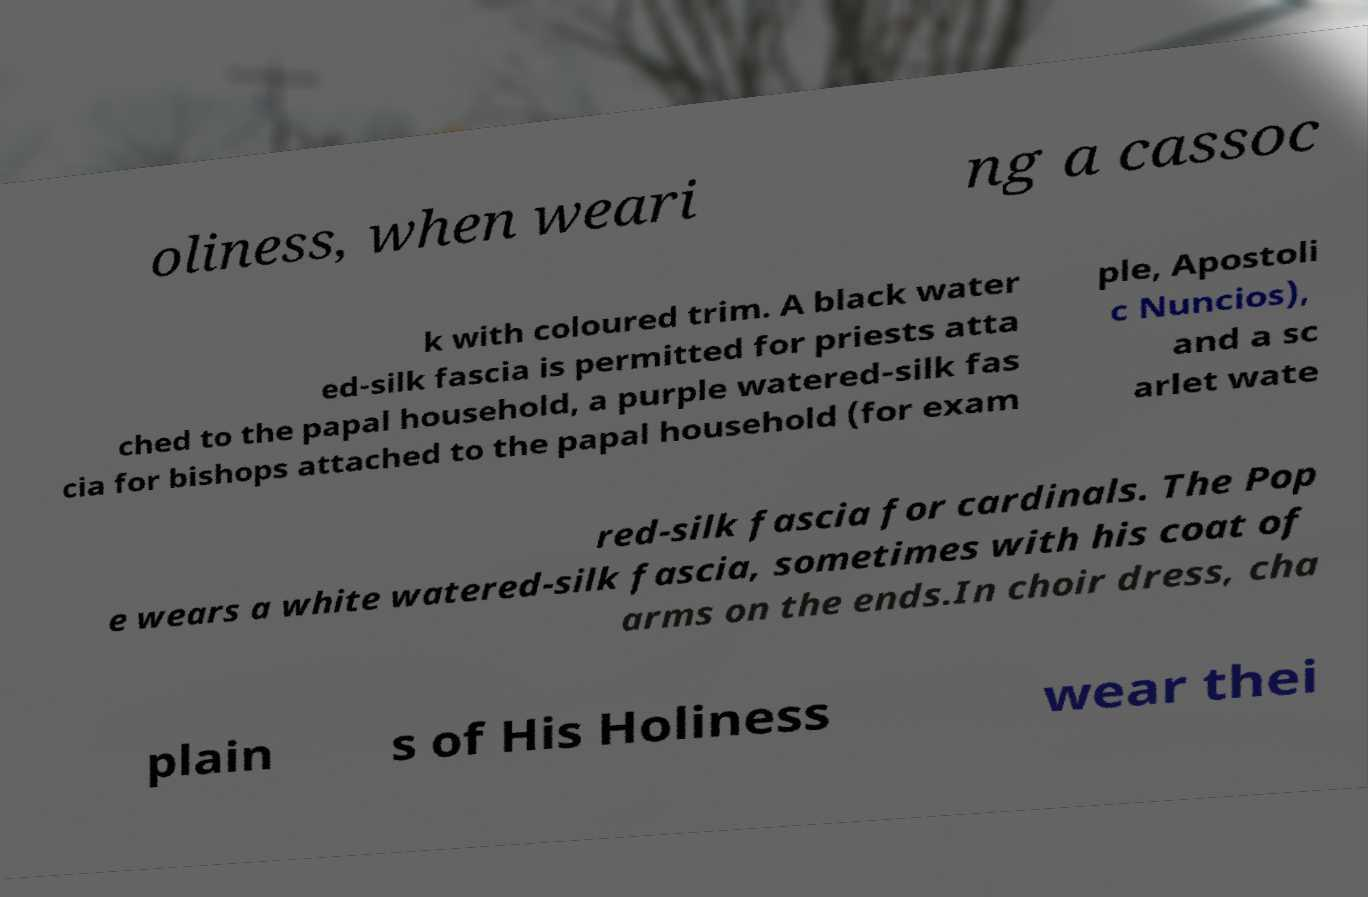Could you assist in decoding the text presented in this image and type it out clearly? oliness, when weari ng a cassoc k with coloured trim. A black water ed-silk fascia is permitted for priests atta ched to the papal household, a purple watered-silk fas cia for bishops attached to the papal household (for exam ple, Apostoli c Nuncios), and a sc arlet wate red-silk fascia for cardinals. The Pop e wears a white watered-silk fascia, sometimes with his coat of arms on the ends.In choir dress, cha plain s of His Holiness wear thei 